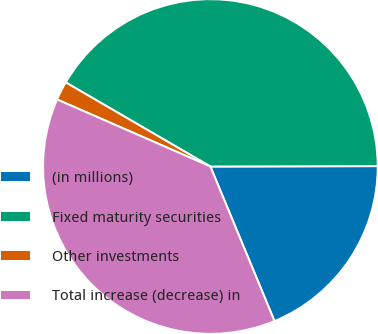<chart> <loc_0><loc_0><loc_500><loc_500><pie_chart><fcel>(in millions)<fcel>Fixed maturity securities<fcel>Other investments<fcel>Total increase (decrease) in<nl><fcel>18.78%<fcel>41.58%<fcel>1.82%<fcel>37.82%<nl></chart> 